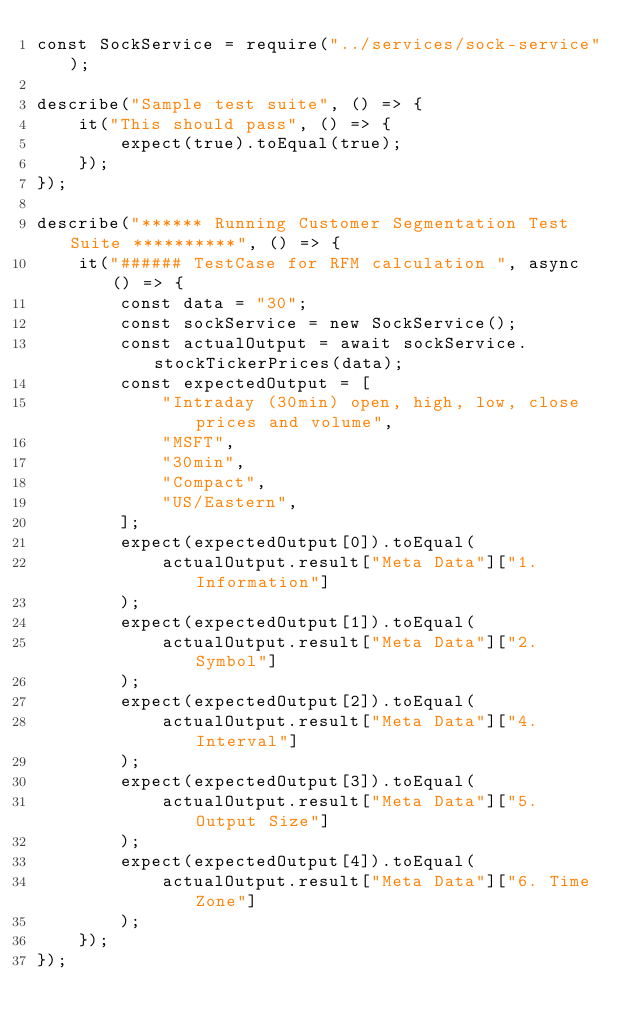<code> <loc_0><loc_0><loc_500><loc_500><_JavaScript_>const SockService = require("../services/sock-service");

describe("Sample test suite", () => {
    it("This should pass", () => {
        expect(true).toEqual(true);
    });
});

describe("****** Running Customer Segmentation Test Suite **********", () => {
    it("###### TestCase for RFM calculation ", async () => {
        const data = "30";
        const sockService = new SockService();
        const actualOutput = await sockService.stockTickerPrices(data);
        const expectedOutput = [
            "Intraday (30min) open, high, low, close prices and volume",
            "MSFT",
            "30min",
            "Compact",
            "US/Eastern",
        ];
        expect(expectedOutput[0]).toEqual(
            actualOutput.result["Meta Data"]["1. Information"]
        );
        expect(expectedOutput[1]).toEqual(
            actualOutput.result["Meta Data"]["2. Symbol"]
        );
        expect(expectedOutput[2]).toEqual(
            actualOutput.result["Meta Data"]["4. Interval"]
        );
        expect(expectedOutput[3]).toEqual(
            actualOutput.result["Meta Data"]["5. Output Size"]
        );
        expect(expectedOutput[4]).toEqual(
            actualOutput.result["Meta Data"]["6. Time Zone"]
        );
    });
});
</code> 